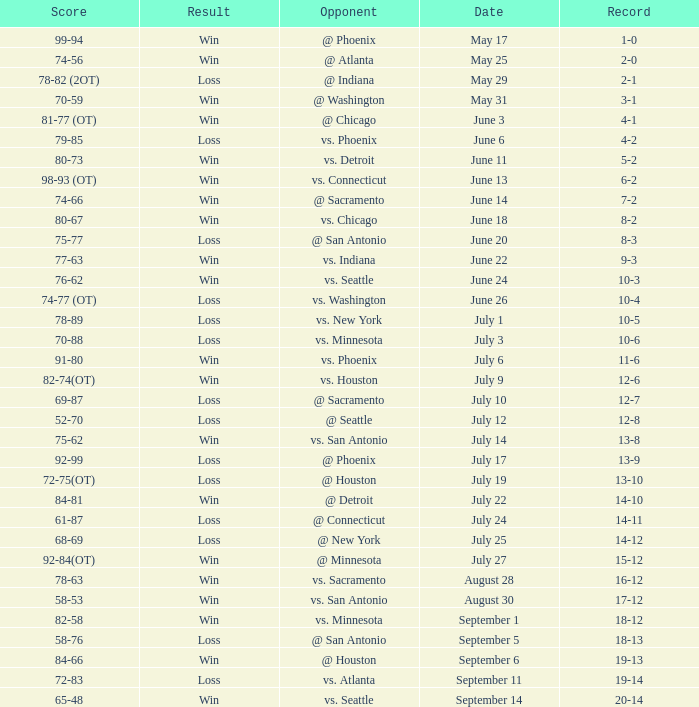What is the Record of the game on September 6? 19-13. 